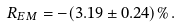Convert formula to latex. <formula><loc_0><loc_0><loc_500><loc_500>R _ { E M } = - ( 3 . 1 9 \pm 0 . 2 4 ) \% \, .</formula> 